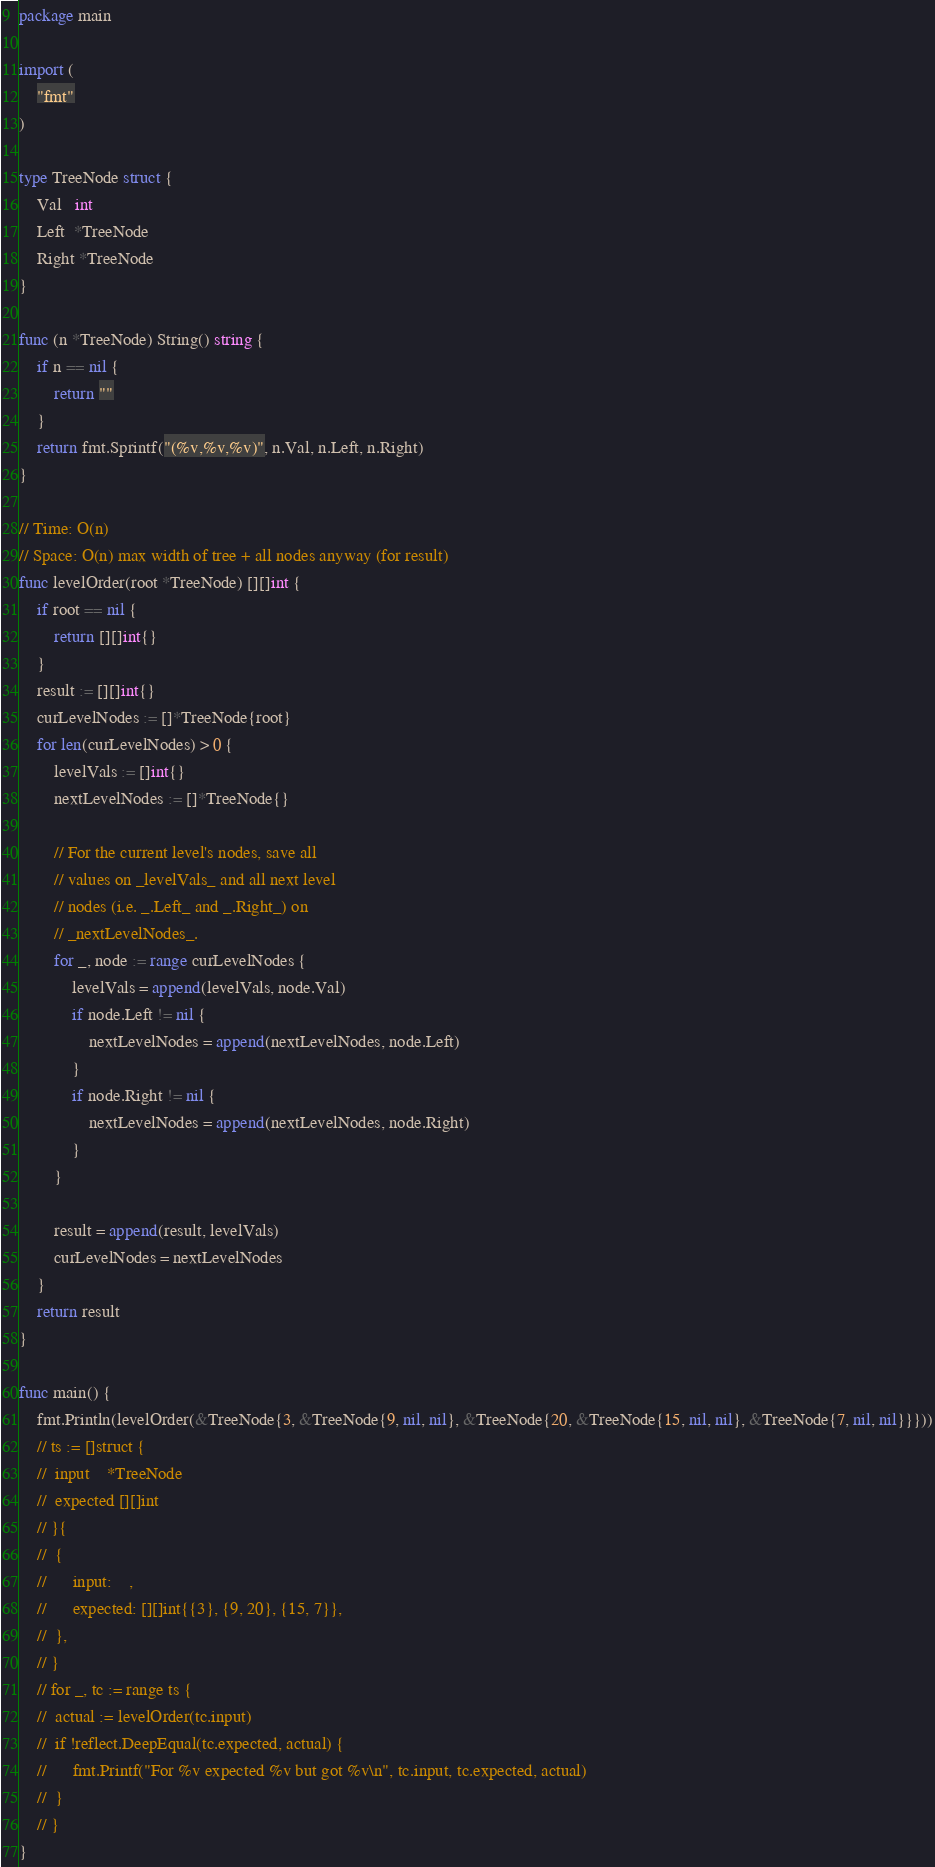Convert code to text. <code><loc_0><loc_0><loc_500><loc_500><_Go_>package main

import (
	"fmt"
)

type TreeNode struct {
	Val   int
	Left  *TreeNode
	Right *TreeNode
}

func (n *TreeNode) String() string {
	if n == nil {
		return ""
	}
	return fmt.Sprintf("(%v,%v,%v)", n.Val, n.Left, n.Right)
}

// Time: O(n)
// Space: O(n) max width of tree + all nodes anyway (for result)
func levelOrder(root *TreeNode) [][]int {
	if root == nil {
		return [][]int{}
	}
	result := [][]int{}
	curLevelNodes := []*TreeNode{root}
	for len(curLevelNodes) > 0 {
		levelVals := []int{}
		nextLevelNodes := []*TreeNode{}

		// For the current level's nodes, save all
		// values on _levelVals_ and all next level
		// nodes (i.e. _.Left_ and _.Right_) on
		// _nextLevelNodes_.
		for _, node := range curLevelNodes {
			levelVals = append(levelVals, node.Val)
			if node.Left != nil {
				nextLevelNodes = append(nextLevelNodes, node.Left)
			}
			if node.Right != nil {
				nextLevelNodes = append(nextLevelNodes, node.Right)
			}
		}

		result = append(result, levelVals)
		curLevelNodes = nextLevelNodes
	}
	return result
}

func main() {
	fmt.Println(levelOrder(&TreeNode{3, &TreeNode{9, nil, nil}, &TreeNode{20, &TreeNode{15, nil, nil}, &TreeNode{7, nil, nil}}}))
	// ts := []struct {
	// 	input    *TreeNode
	// 	expected [][]int
	// }{
	// 	{
	// 		input:    ,
	// 		expected: [][]int{{3}, {9, 20}, {15, 7}},
	// 	},
	// }
	// for _, tc := range ts {
	// 	actual := levelOrder(tc.input)
	// 	if !reflect.DeepEqual(tc.expected, actual) {
	// 		fmt.Printf("For %v expected %v but got %v\n", tc.input, tc.expected, actual)
	// 	}
	// }
}
</code> 